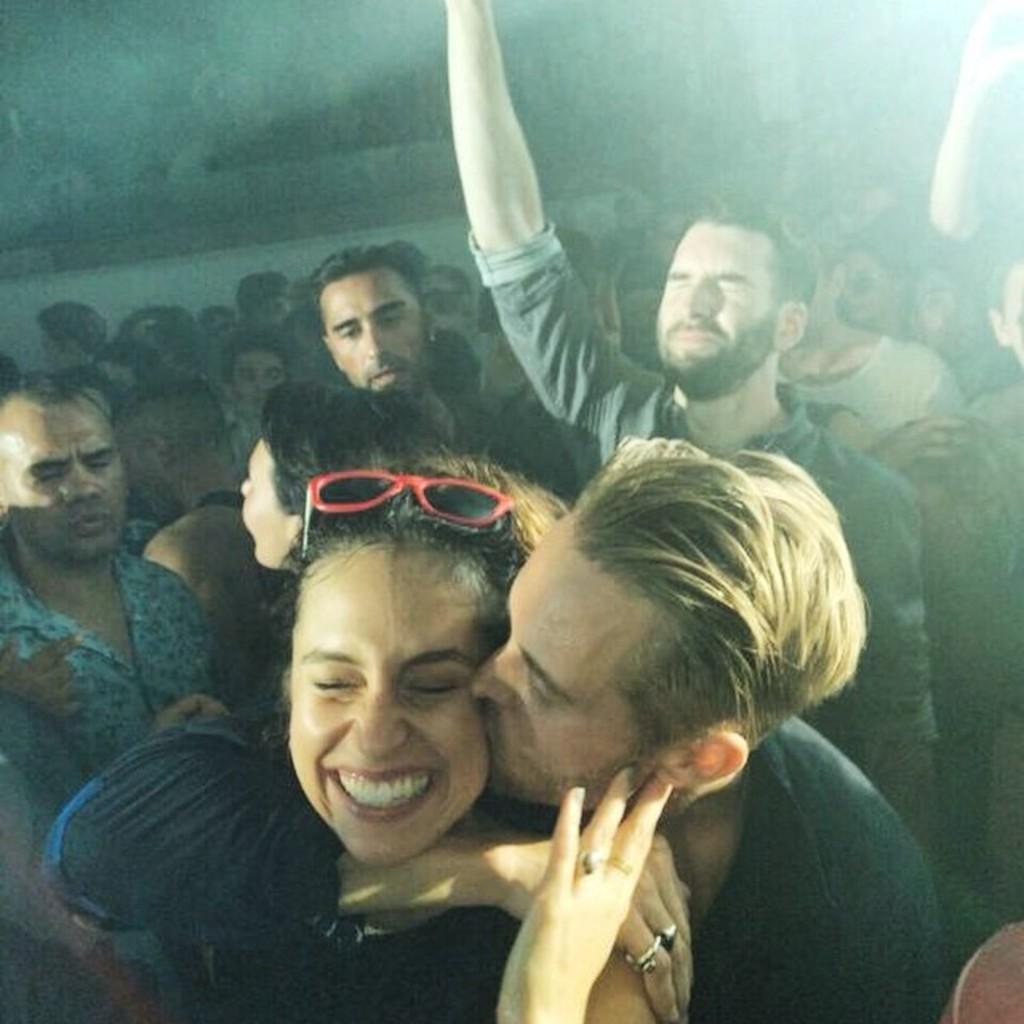Please provide a concise description of this image. In this picture there are people, among them there's a man kissing a woman. In the background of the image it is dark. 